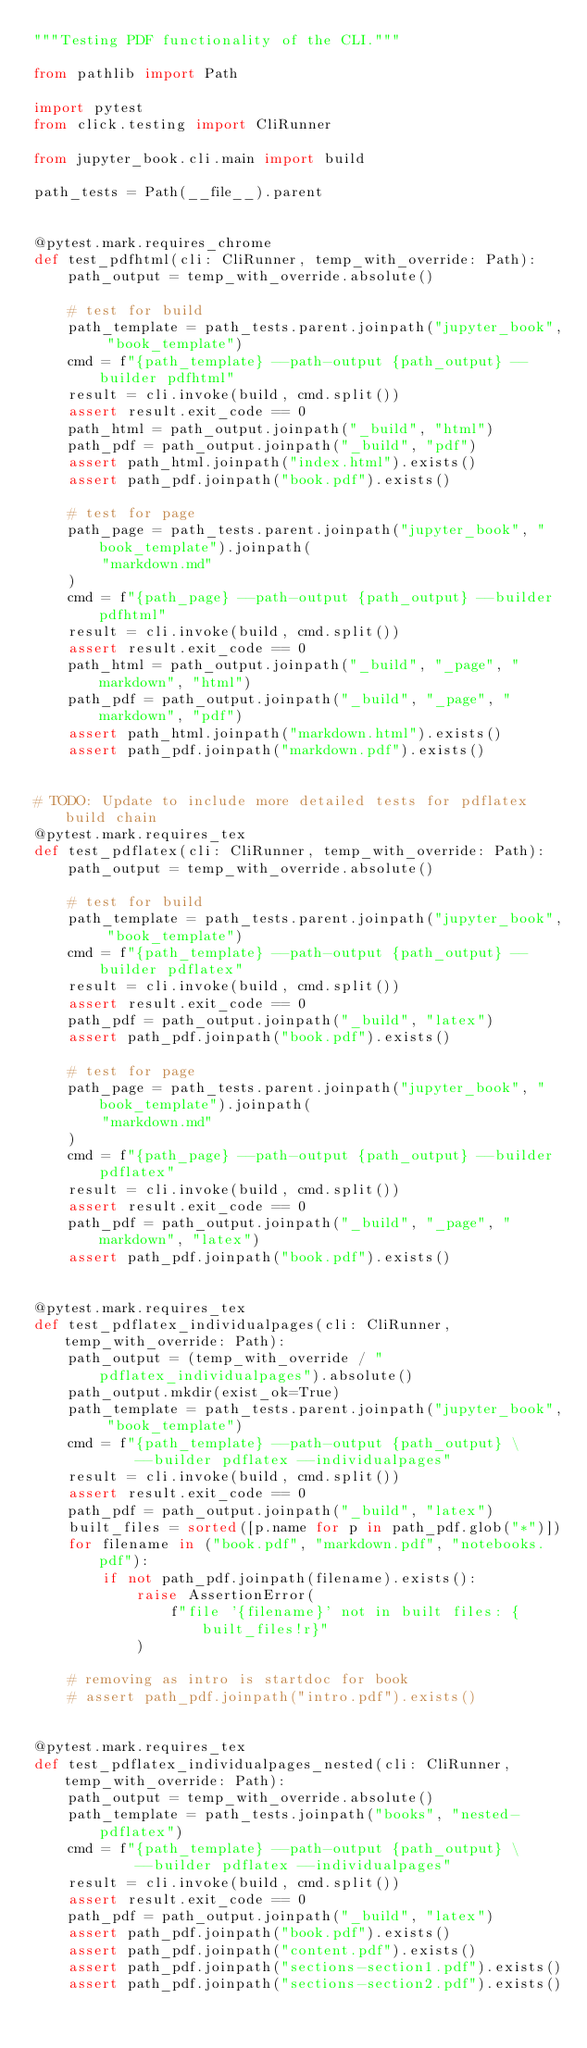<code> <loc_0><loc_0><loc_500><loc_500><_Python_>"""Testing PDF functionality of the CLI."""

from pathlib import Path

import pytest
from click.testing import CliRunner

from jupyter_book.cli.main import build

path_tests = Path(__file__).parent


@pytest.mark.requires_chrome
def test_pdfhtml(cli: CliRunner, temp_with_override: Path):
    path_output = temp_with_override.absolute()

    # test for build
    path_template = path_tests.parent.joinpath("jupyter_book", "book_template")
    cmd = f"{path_template} --path-output {path_output} --builder pdfhtml"
    result = cli.invoke(build, cmd.split())
    assert result.exit_code == 0
    path_html = path_output.joinpath("_build", "html")
    path_pdf = path_output.joinpath("_build", "pdf")
    assert path_html.joinpath("index.html").exists()
    assert path_pdf.joinpath("book.pdf").exists()

    # test for page
    path_page = path_tests.parent.joinpath("jupyter_book", "book_template").joinpath(
        "markdown.md"
    )
    cmd = f"{path_page} --path-output {path_output} --builder pdfhtml"
    result = cli.invoke(build, cmd.split())
    assert result.exit_code == 0
    path_html = path_output.joinpath("_build", "_page", "markdown", "html")
    path_pdf = path_output.joinpath("_build", "_page", "markdown", "pdf")
    assert path_html.joinpath("markdown.html").exists()
    assert path_pdf.joinpath("markdown.pdf").exists()


# TODO: Update to include more detailed tests for pdflatex build chain
@pytest.mark.requires_tex
def test_pdflatex(cli: CliRunner, temp_with_override: Path):
    path_output = temp_with_override.absolute()

    # test for build
    path_template = path_tests.parent.joinpath("jupyter_book", "book_template")
    cmd = f"{path_template} --path-output {path_output} --builder pdflatex"
    result = cli.invoke(build, cmd.split())
    assert result.exit_code == 0
    path_pdf = path_output.joinpath("_build", "latex")
    assert path_pdf.joinpath("book.pdf").exists()

    # test for page
    path_page = path_tests.parent.joinpath("jupyter_book", "book_template").joinpath(
        "markdown.md"
    )
    cmd = f"{path_page} --path-output {path_output} --builder pdflatex"
    result = cli.invoke(build, cmd.split())
    assert result.exit_code == 0
    path_pdf = path_output.joinpath("_build", "_page", "markdown", "latex")
    assert path_pdf.joinpath("book.pdf").exists()


@pytest.mark.requires_tex
def test_pdflatex_individualpages(cli: CliRunner, temp_with_override: Path):
    path_output = (temp_with_override / "pdflatex_individualpages").absolute()
    path_output.mkdir(exist_ok=True)
    path_template = path_tests.parent.joinpath("jupyter_book", "book_template")
    cmd = f"{path_template} --path-output {path_output} \
            --builder pdflatex --individualpages"
    result = cli.invoke(build, cmd.split())
    assert result.exit_code == 0
    path_pdf = path_output.joinpath("_build", "latex")
    built_files = sorted([p.name for p in path_pdf.glob("*")])
    for filename in ("book.pdf", "markdown.pdf", "notebooks.pdf"):
        if not path_pdf.joinpath(filename).exists():
            raise AssertionError(
                f"file '{filename}' not in built files: {built_files!r}"
            )

    # removing as intro is startdoc for book
    # assert path_pdf.joinpath("intro.pdf").exists()


@pytest.mark.requires_tex
def test_pdflatex_individualpages_nested(cli: CliRunner, temp_with_override: Path):
    path_output = temp_with_override.absolute()
    path_template = path_tests.joinpath("books", "nested-pdflatex")
    cmd = f"{path_template} --path-output {path_output} \
            --builder pdflatex --individualpages"
    result = cli.invoke(build, cmd.split())
    assert result.exit_code == 0
    path_pdf = path_output.joinpath("_build", "latex")
    assert path_pdf.joinpath("book.pdf").exists()
    assert path_pdf.joinpath("content.pdf").exists()
    assert path_pdf.joinpath("sections-section1.pdf").exists()
    assert path_pdf.joinpath("sections-section2.pdf").exists()
</code> 